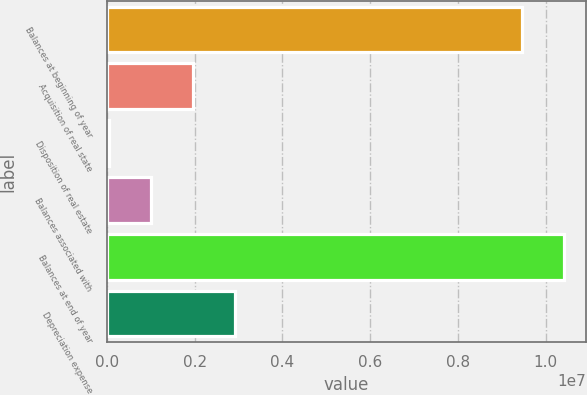Convert chart. <chart><loc_0><loc_0><loc_500><loc_500><bar_chart><fcel>Balances at beginning of year<fcel>Acquisition of real state<fcel>Disposition of real estate<fcel>Balances associated with<fcel>Balances at end of year<fcel>Depreciation expense<nl><fcel>9.44975e+06<fcel>1.96534e+06<fcel>60134<fcel>1.01274e+06<fcel>1.04024e+07<fcel>2.91794e+06<nl></chart> 